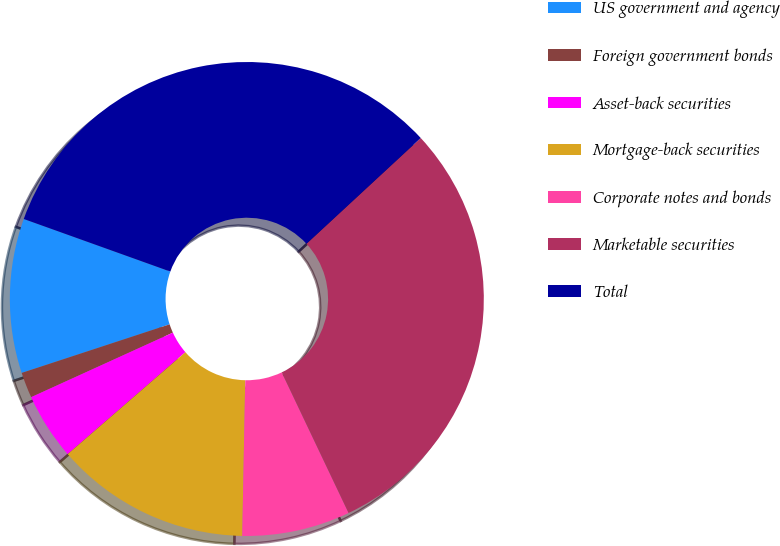Convert chart to OTSL. <chart><loc_0><loc_0><loc_500><loc_500><pie_chart><fcel>US government and agency<fcel>Foreign government bonds<fcel>Asset-back securities<fcel>Mortgage-back securities<fcel>Corporate notes and bonds<fcel>Marketable securities<fcel>Total<nl><fcel>10.53%<fcel>1.75%<fcel>4.56%<fcel>13.33%<fcel>7.37%<fcel>29.82%<fcel>32.63%<nl></chart> 